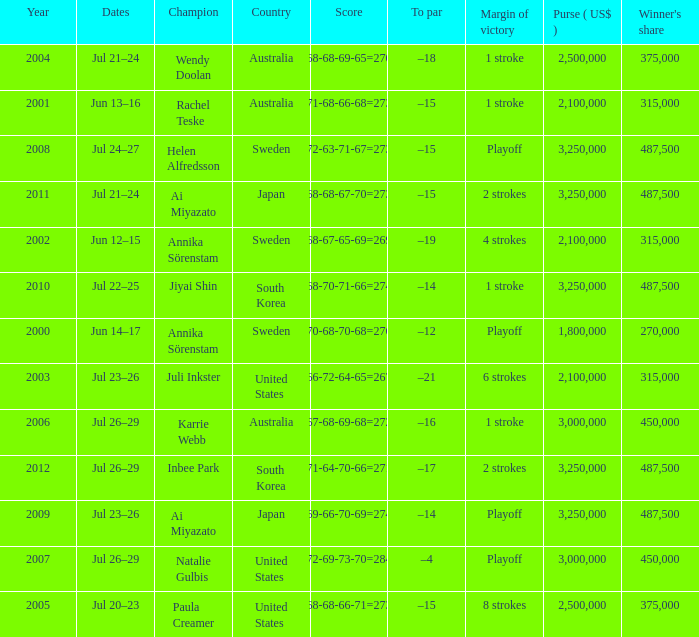Which Country has a Score of 70-68-70-68=276? Sweden. 